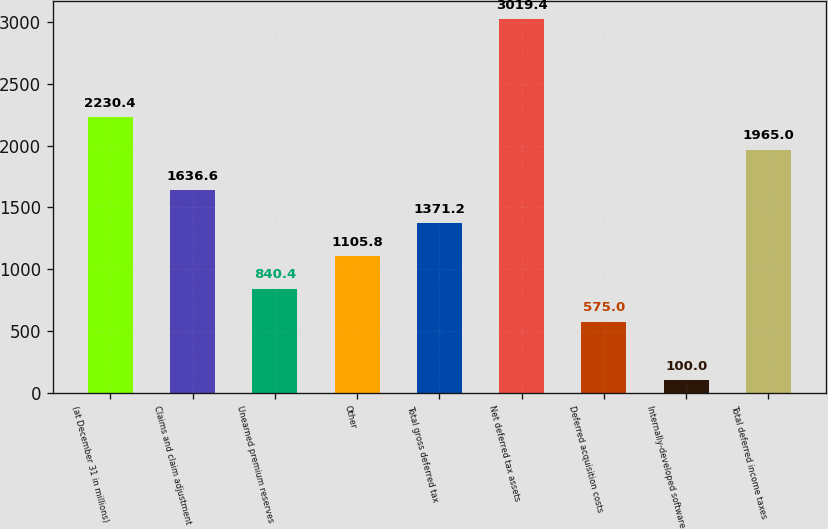Convert chart. <chart><loc_0><loc_0><loc_500><loc_500><bar_chart><fcel>(at December 31 in millions)<fcel>Claims and claim adjustment<fcel>Unearned premium reserves<fcel>Other<fcel>Total gross deferred tax<fcel>Net deferred tax assets<fcel>Deferred acquisition costs<fcel>Internally-developed software<fcel>Total deferred income taxes<nl><fcel>2230.4<fcel>1636.6<fcel>840.4<fcel>1105.8<fcel>1371.2<fcel>3019.4<fcel>575<fcel>100<fcel>1965<nl></chart> 